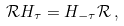<formula> <loc_0><loc_0><loc_500><loc_500>\mathcal { R } H _ { \tau } = H _ { - \tau } \mathcal { R } \, ,</formula> 